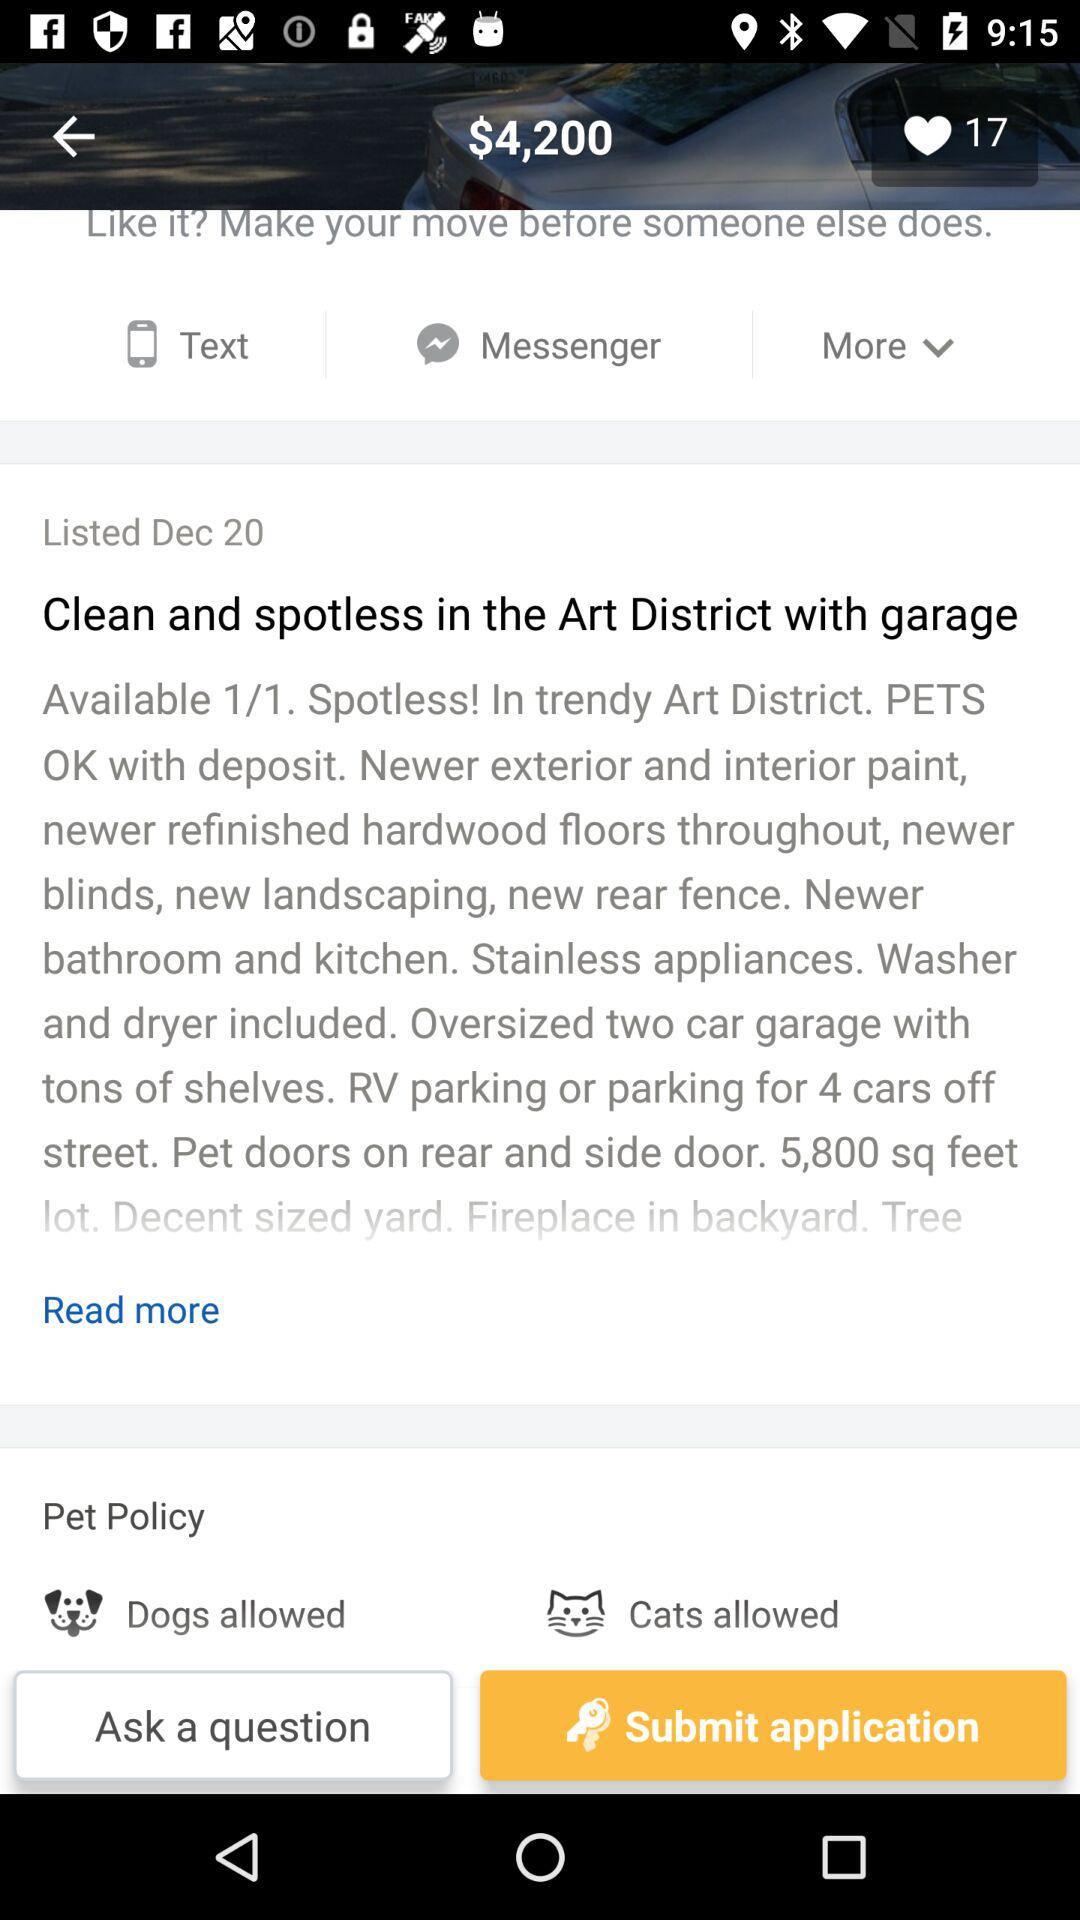What date was this application written? This application was written on December 20. 